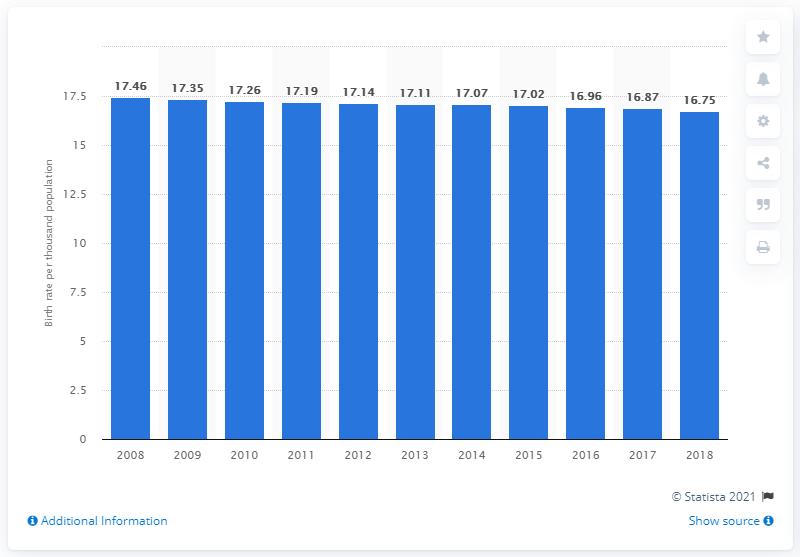Give some essential details in this illustration. In 2018, the crude birth rate in Malaysia was 16.75. 